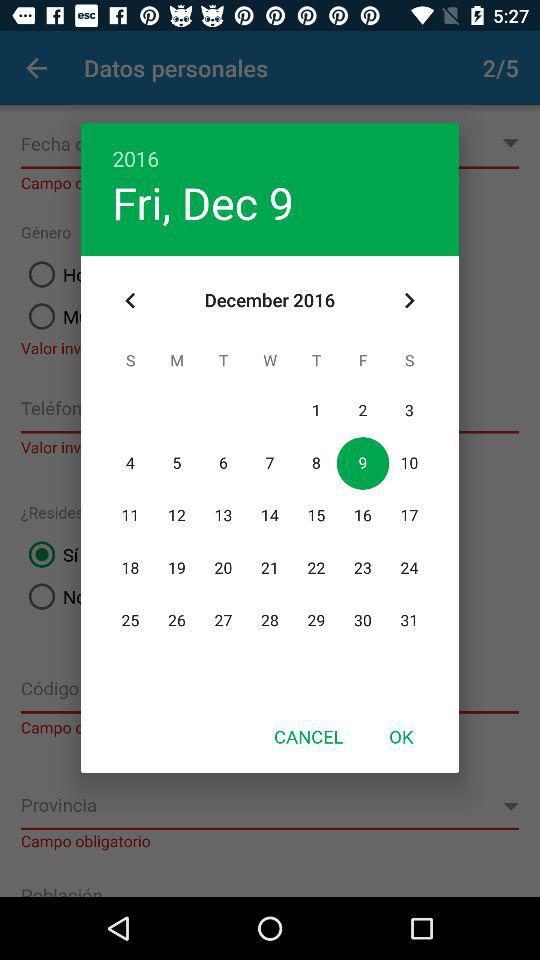What is the selected date? The selected date is Friday, December 9, 2016. 